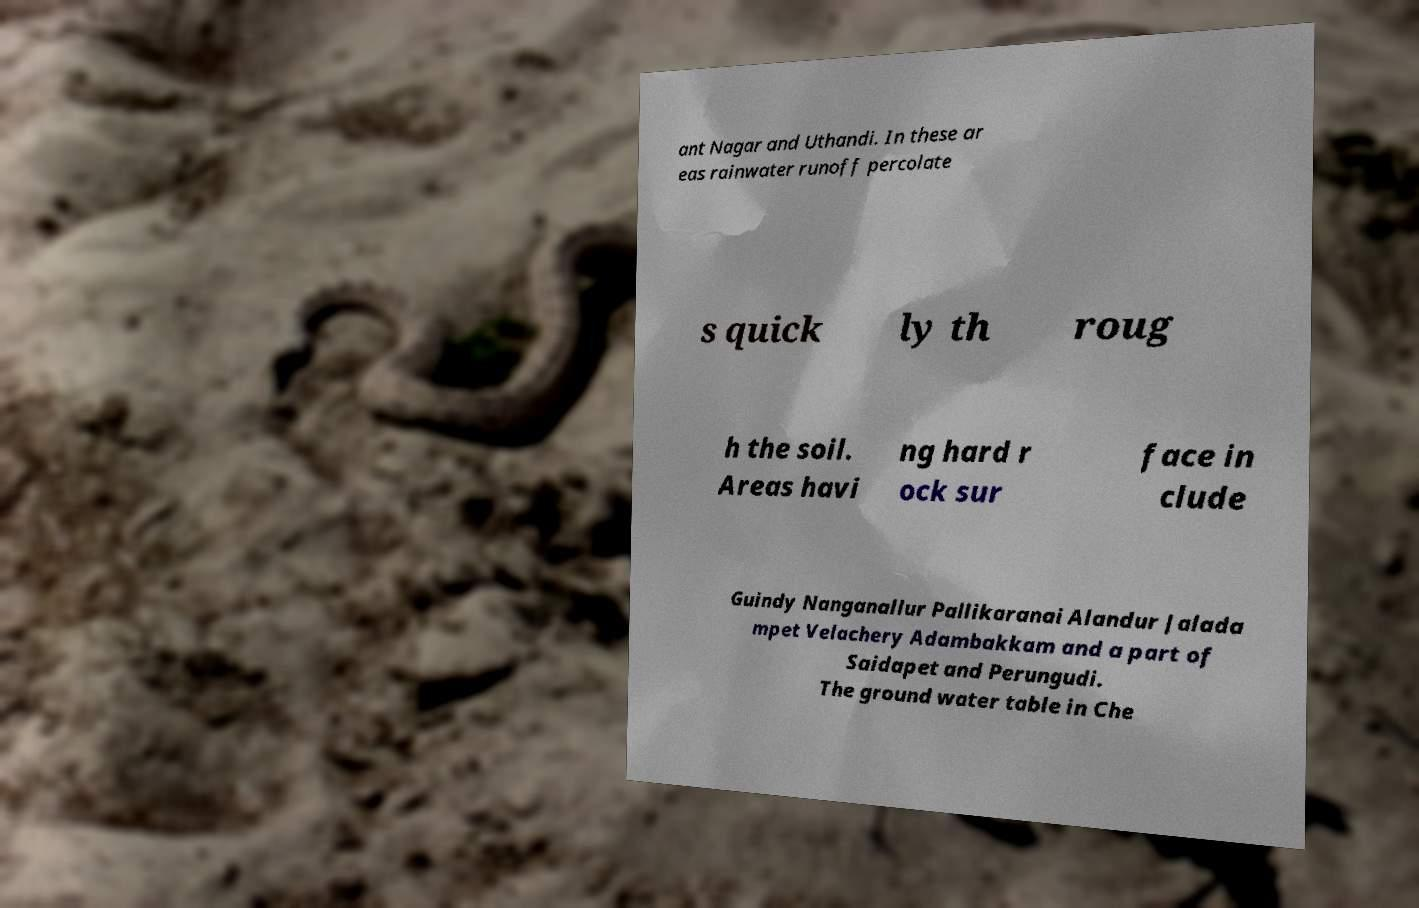Please read and relay the text visible in this image. What does it say? ant Nagar and Uthandi. In these ar eas rainwater runoff percolate s quick ly th roug h the soil. Areas havi ng hard r ock sur face in clude Guindy Nanganallur Pallikaranai Alandur Jalada mpet Velachery Adambakkam and a part of Saidapet and Perungudi. The ground water table in Che 